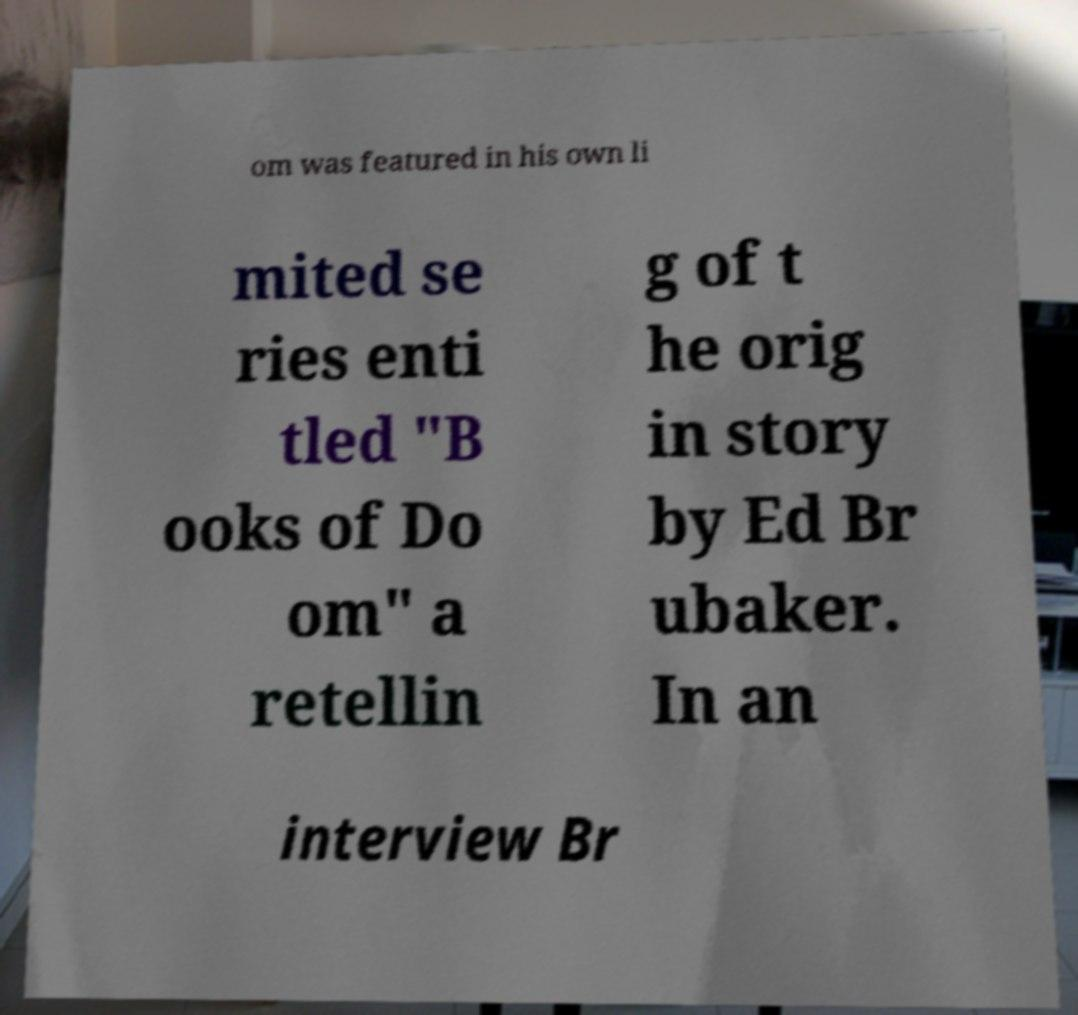Can you read and provide the text displayed in the image?This photo seems to have some interesting text. Can you extract and type it out for me? om was featured in his own li mited se ries enti tled "B ooks of Do om" a retellin g of t he orig in story by Ed Br ubaker. In an interview Br 